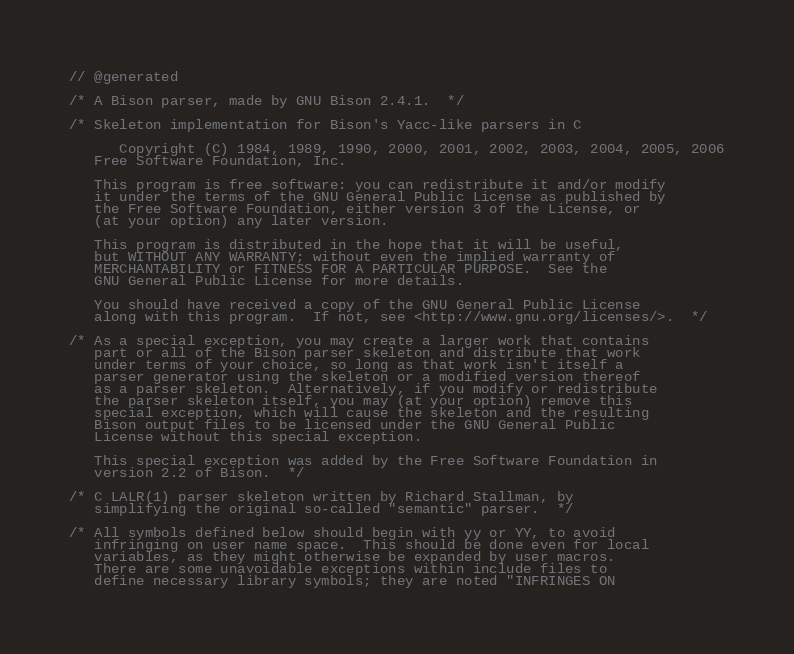Convert code to text. <code><loc_0><loc_0><loc_500><loc_500><_C++_>// @generated

/* A Bison parser, made by GNU Bison 2.4.1.  */

/* Skeleton implementation for Bison's Yacc-like parsers in C
   
      Copyright (C) 1984, 1989, 1990, 2000, 2001, 2002, 2003, 2004, 2005, 2006
   Free Software Foundation, Inc.
   
   This program is free software: you can redistribute it and/or modify
   it under the terms of the GNU General Public License as published by
   the Free Software Foundation, either version 3 of the License, or
   (at your option) any later version.
   
   This program is distributed in the hope that it will be useful,
   but WITHOUT ANY WARRANTY; without even the implied warranty of
   MERCHANTABILITY or FITNESS FOR A PARTICULAR PURPOSE.  See the
   GNU General Public License for more details.
   
   You should have received a copy of the GNU General Public License
   along with this program.  If not, see <http://www.gnu.org/licenses/>.  */

/* As a special exception, you may create a larger work that contains
   part or all of the Bison parser skeleton and distribute that work
   under terms of your choice, so long as that work isn't itself a
   parser generator using the skeleton or a modified version thereof
   as a parser skeleton.  Alternatively, if you modify or redistribute
   the parser skeleton itself, you may (at your option) remove this
   special exception, which will cause the skeleton and the resulting
   Bison output files to be licensed under the GNU General Public
   License without this special exception.
   
   This special exception was added by the Free Software Foundation in
   version 2.2 of Bison.  */

/* C LALR(1) parser skeleton written by Richard Stallman, by
   simplifying the original so-called "semantic" parser.  */

/* All symbols defined below should begin with yy or YY, to avoid
   infringing on user name space.  This should be done even for local
   variables, as they might otherwise be expanded by user macros.
   There are some unavoidable exceptions within include files to
   define necessary library symbols; they are noted "INFRINGES ON</code> 